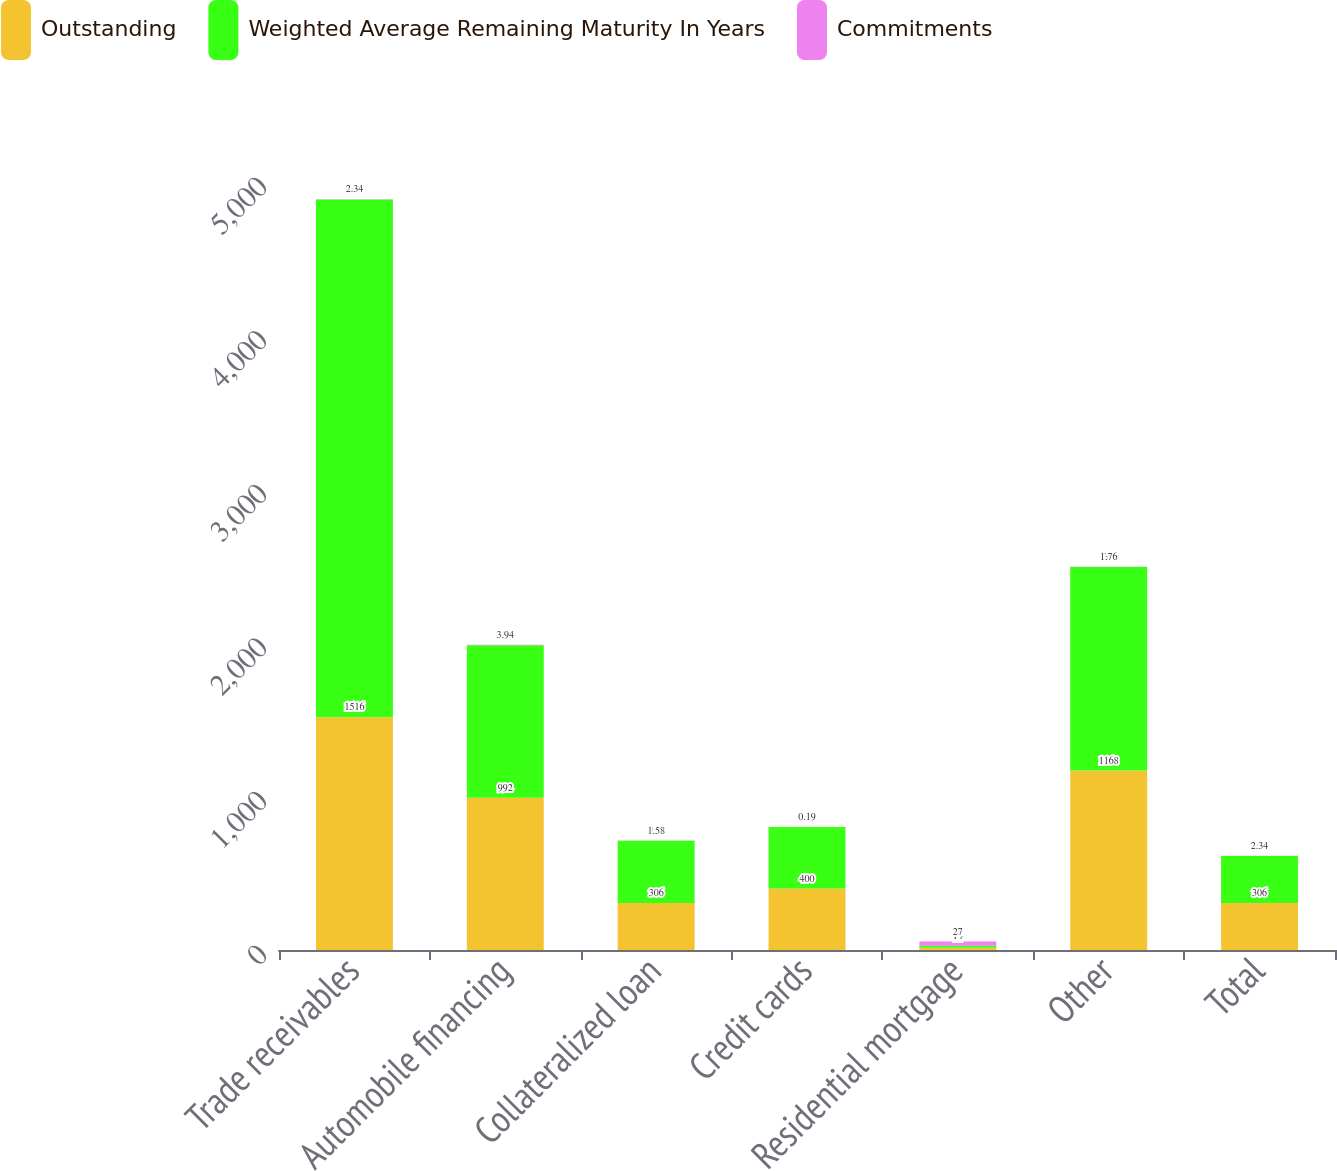<chart> <loc_0><loc_0><loc_500><loc_500><stacked_bar_chart><ecel><fcel>Trade receivables<fcel>Automobile financing<fcel>Collateralized loan<fcel>Credit cards<fcel>Residential mortgage<fcel>Other<fcel>Total<nl><fcel>Outstanding<fcel>1516<fcel>992<fcel>306<fcel>400<fcel>14<fcel>1168<fcel>306<nl><fcel>Weighted Average Remaining Maturity In Years<fcel>3370<fcel>992<fcel>405<fcel>400<fcel>14<fcel>1325<fcel>306<nl><fcel>Commitments<fcel>2.34<fcel>3.94<fcel>1.58<fcel>0.19<fcel>27<fcel>1.76<fcel>2.34<nl></chart> 